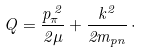<formula> <loc_0><loc_0><loc_500><loc_500>Q = \frac { p _ { \pi } ^ { \, 2 } } { 2 \mu } + \frac { k ^ { 2 } } { 2 m _ { p n } } \, \cdot</formula> 